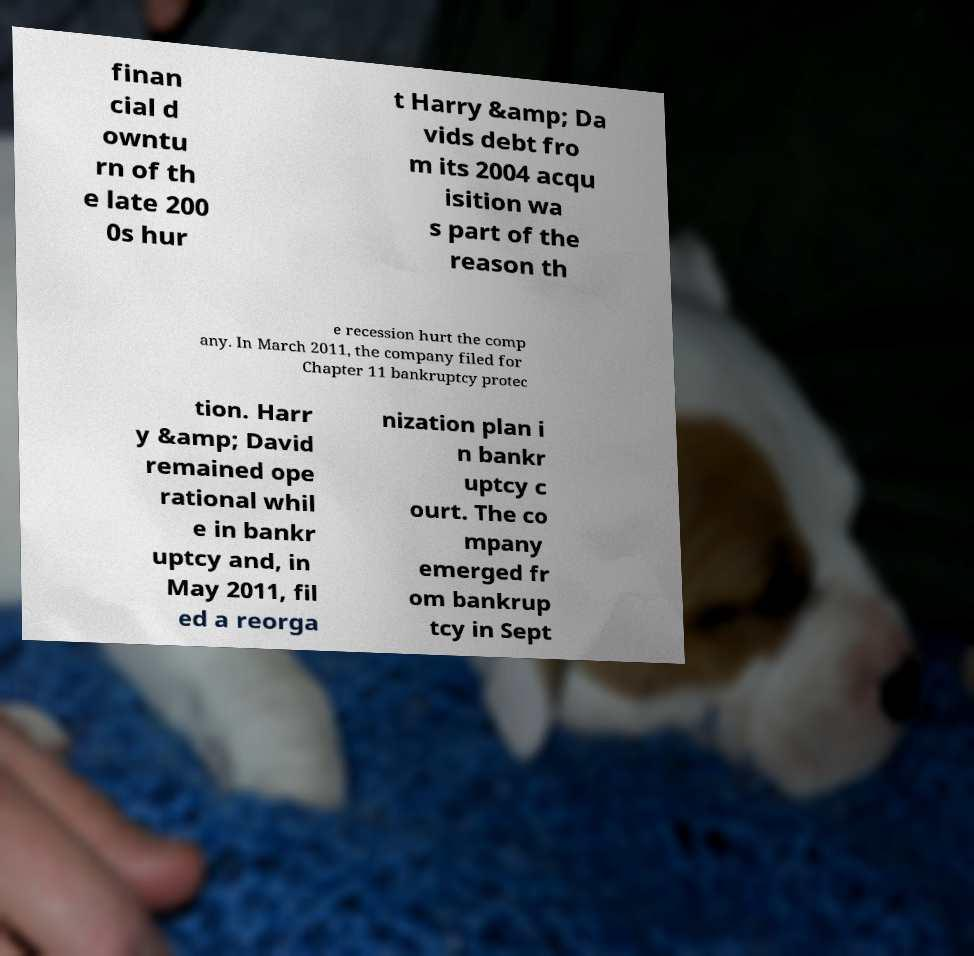Could you extract and type out the text from this image? finan cial d owntu rn of th e late 200 0s hur t Harry &amp; Da vids debt fro m its 2004 acqu isition wa s part of the reason th e recession hurt the comp any. In March 2011, the company filed for Chapter 11 bankruptcy protec tion. Harr y &amp; David remained ope rational whil e in bankr uptcy and, in May 2011, fil ed a reorga nization plan i n bankr uptcy c ourt. The co mpany emerged fr om bankrup tcy in Sept 